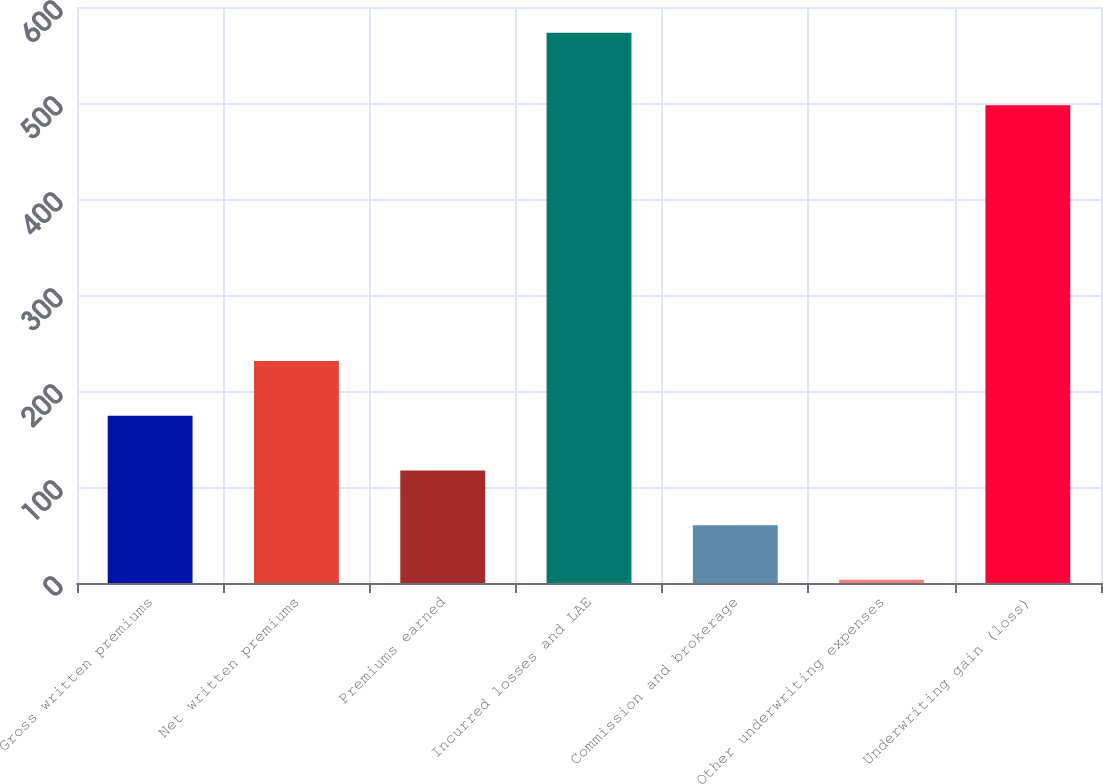Convert chart. <chart><loc_0><loc_0><loc_500><loc_500><bar_chart><fcel>Gross written premiums<fcel>Net written premiums<fcel>Premiums earned<fcel>Incurred losses and LAE<fcel>Commission and brokerage<fcel>Other underwriting expenses<fcel>Underwriting gain (loss)<nl><fcel>174.24<fcel>231.22<fcel>117.26<fcel>573.1<fcel>60.28<fcel>3.3<fcel>497.7<nl></chart> 